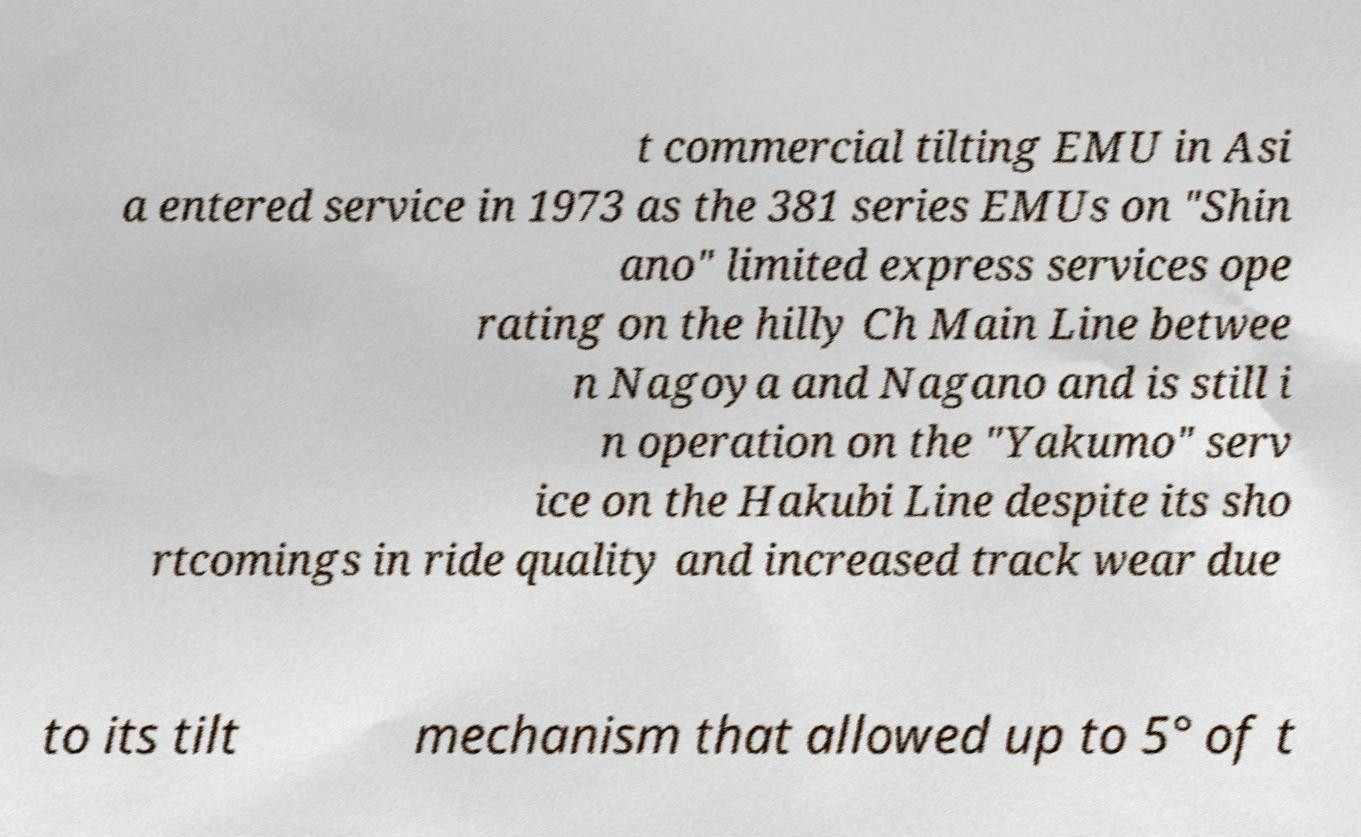Please read and relay the text visible in this image. What does it say? t commercial tilting EMU in Asi a entered service in 1973 as the 381 series EMUs on "Shin ano" limited express services ope rating on the hilly Ch Main Line betwee n Nagoya and Nagano and is still i n operation on the "Yakumo" serv ice on the Hakubi Line despite its sho rtcomings in ride quality and increased track wear due to its tilt mechanism that allowed up to 5° of t 